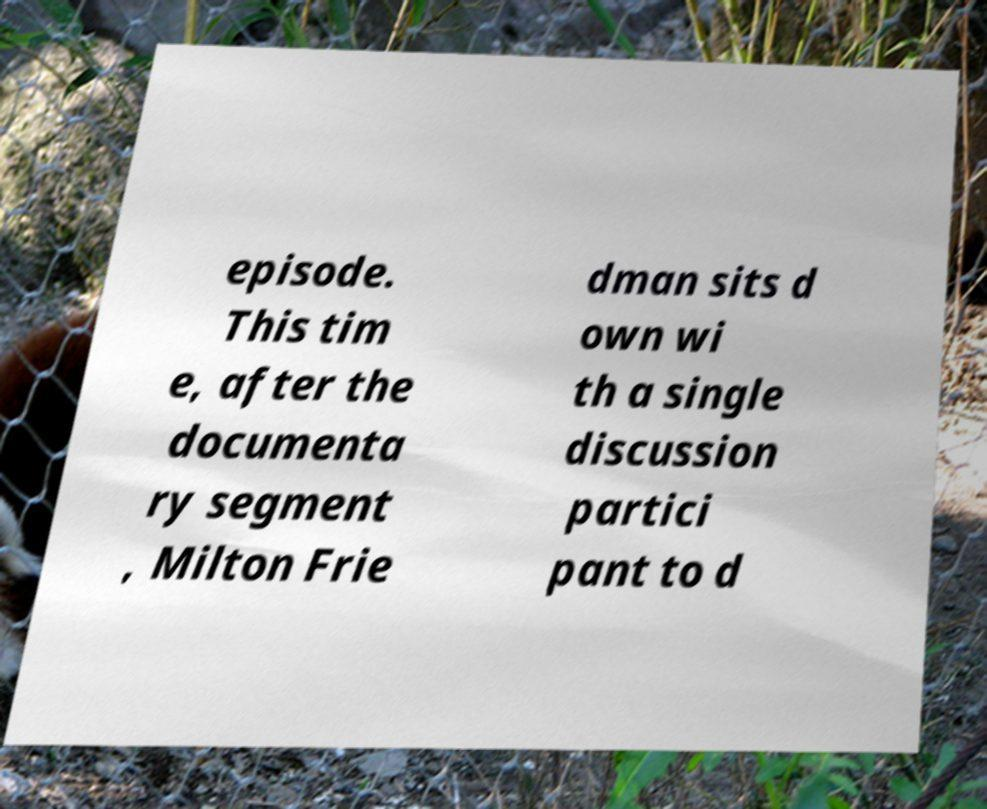Please identify and transcribe the text found in this image. episode. This tim e, after the documenta ry segment , Milton Frie dman sits d own wi th a single discussion partici pant to d 